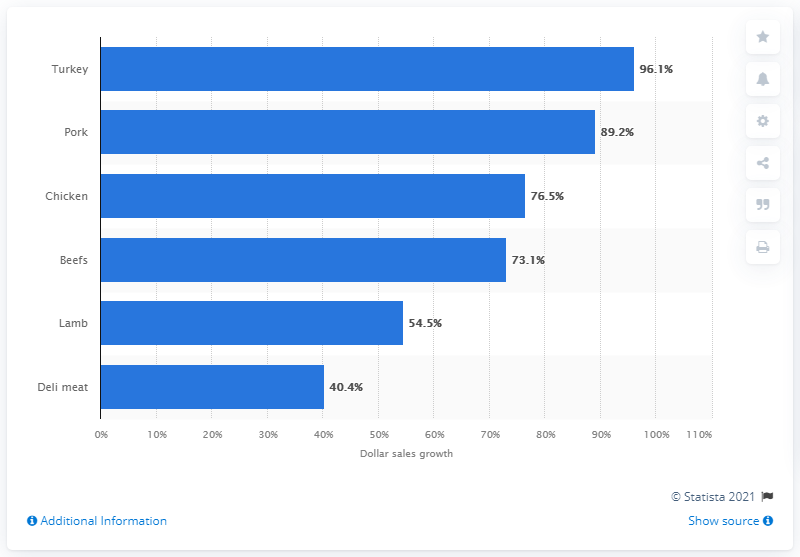Specify some key components in this picture. The sales of turkey meat in dollars increased significantly during the week of March 15, 2020, with a growth of 96.1%. During the week of March 15, 2020, the dollar sales of deli meat appreciated by 40.4%. 